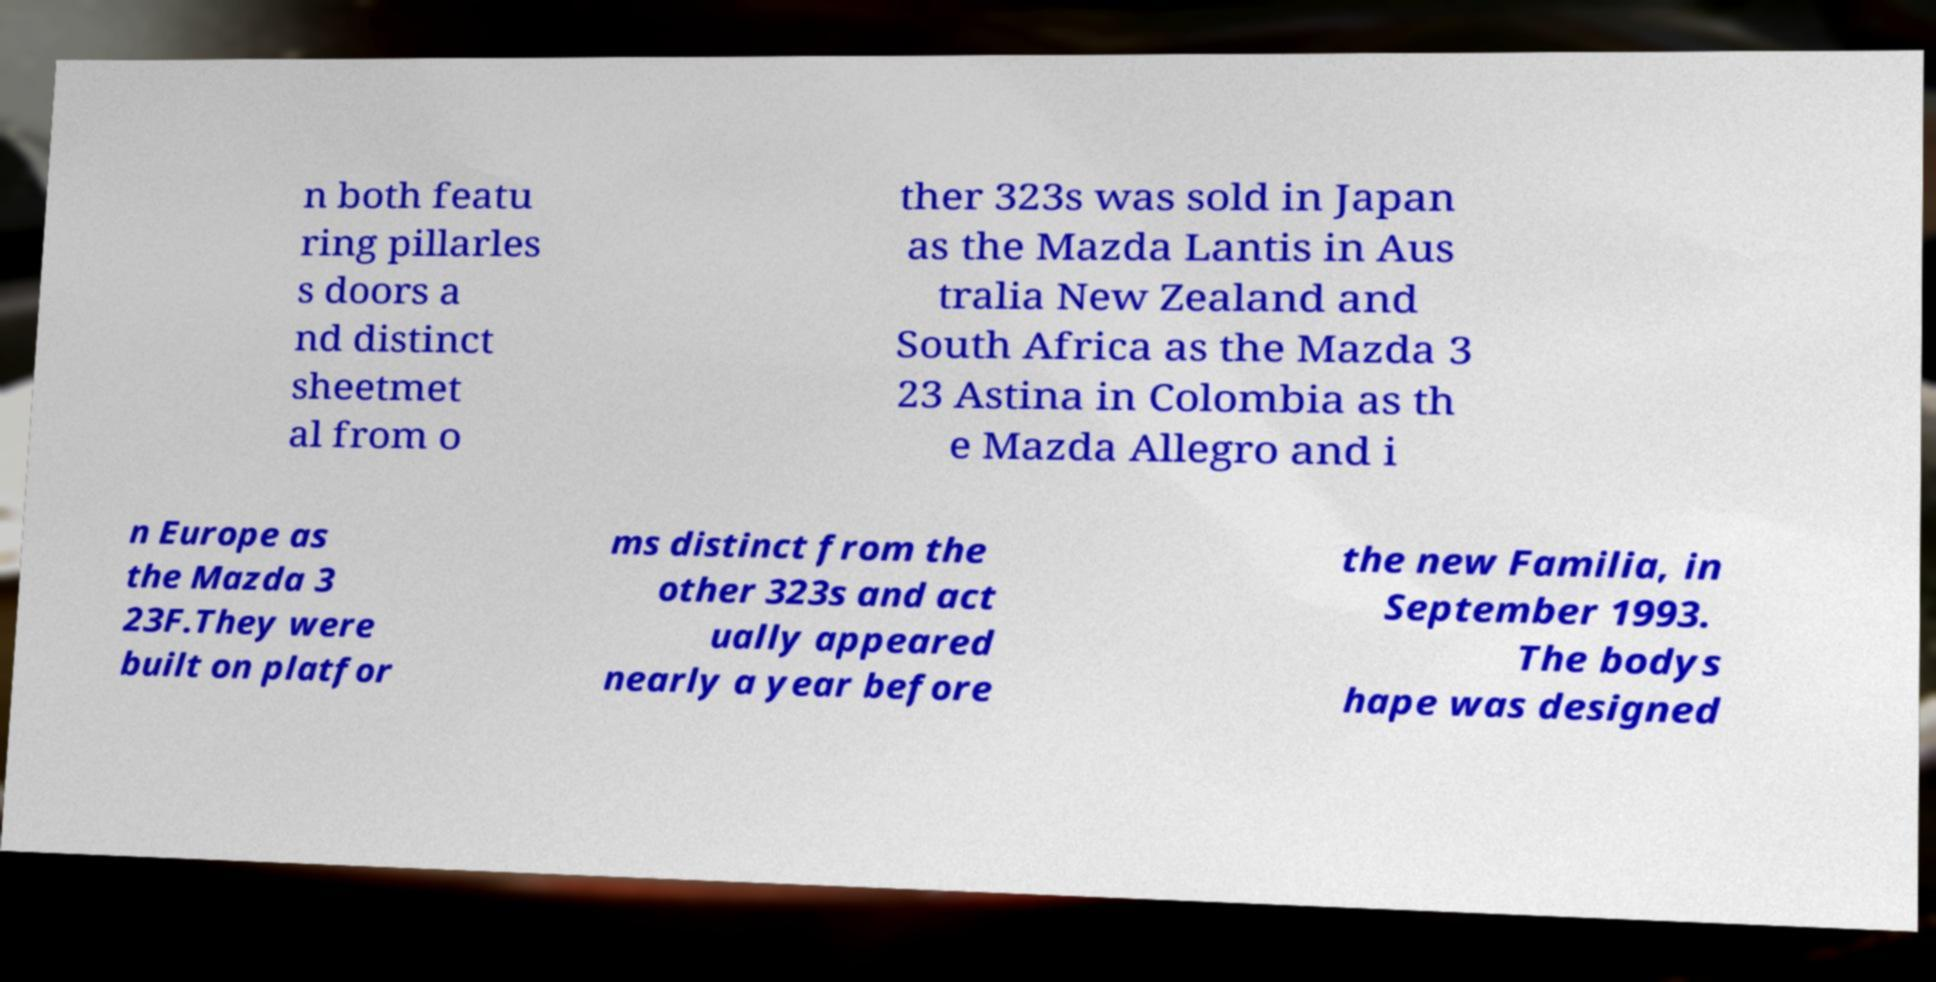Can you read and provide the text displayed in the image?This photo seems to have some interesting text. Can you extract and type it out for me? n both featu ring pillarles s doors a nd distinct sheetmet al from o ther 323s was sold in Japan as the Mazda Lantis in Aus tralia New Zealand and South Africa as the Mazda 3 23 Astina in Colombia as th e Mazda Allegro and i n Europe as the Mazda 3 23F.They were built on platfor ms distinct from the other 323s and act ually appeared nearly a year before the new Familia, in September 1993. The bodys hape was designed 